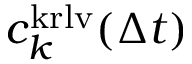<formula> <loc_0><loc_0><loc_500><loc_500>c _ { k } ^ { k r l v } ( \Delta t )</formula> 